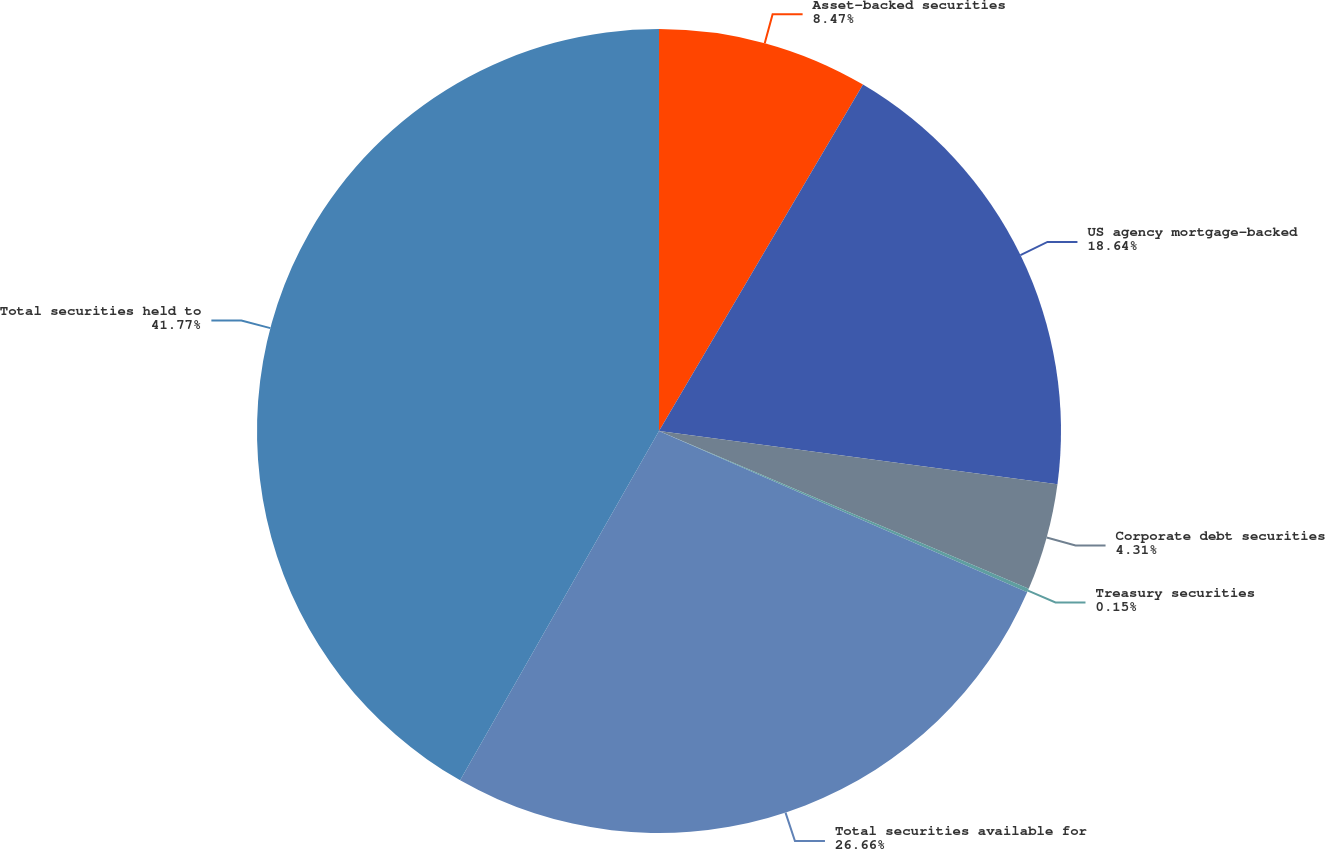<chart> <loc_0><loc_0><loc_500><loc_500><pie_chart><fcel>Asset-backed securities<fcel>US agency mortgage-backed<fcel>Corporate debt securities<fcel>Treasury securities<fcel>Total securities available for<fcel>Total securities held to<nl><fcel>8.47%<fcel>18.64%<fcel>4.31%<fcel>0.15%<fcel>26.66%<fcel>41.76%<nl></chart> 